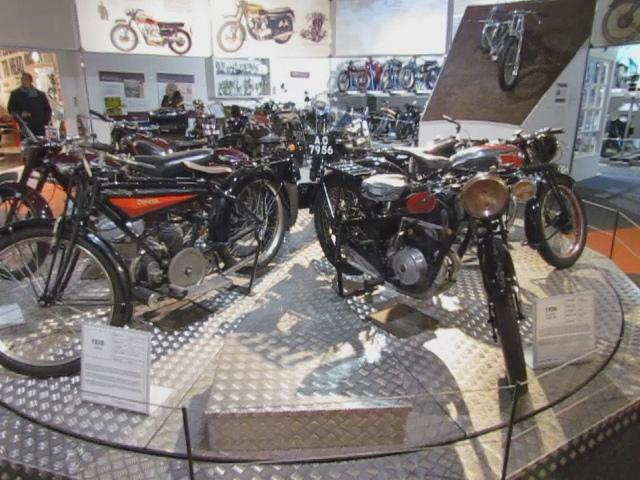What type room is this? Please explain your reasoning. showroom. The motorcycles are displayed for sale. 